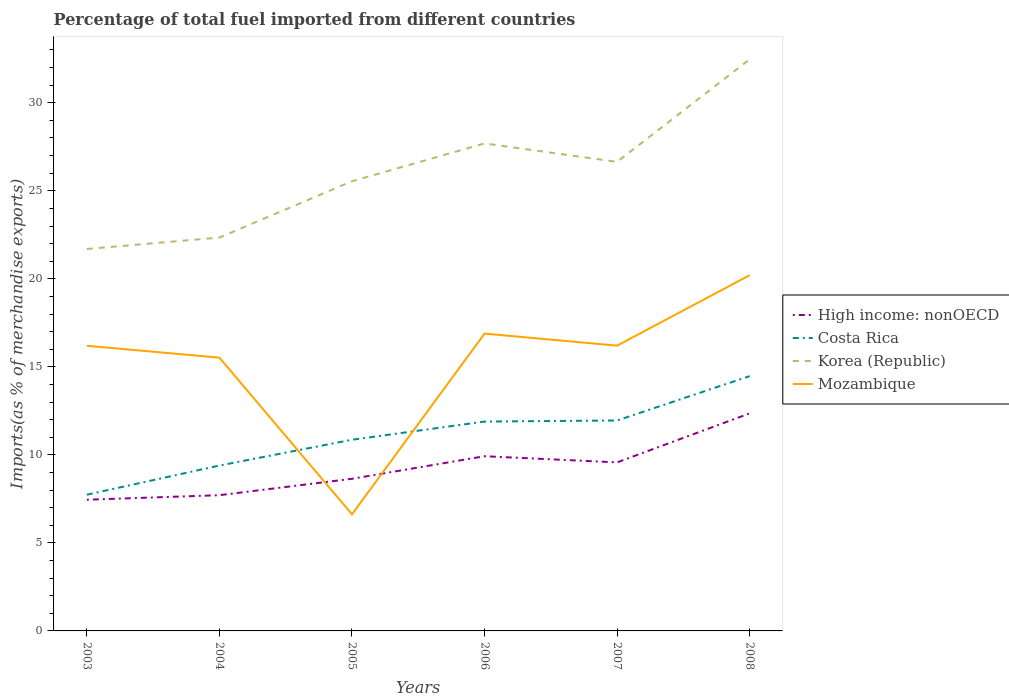Across all years, what is the maximum percentage of imports to different countries in Mozambique?
Give a very brief answer. 6.62. What is the total percentage of imports to different countries in Mozambique in the graph?
Offer a very short reply. 0.67. What is the difference between the highest and the second highest percentage of imports to different countries in Korea (Republic)?
Ensure brevity in your answer.  10.77. How many lines are there?
Provide a short and direct response. 4. How many years are there in the graph?
Provide a short and direct response. 6. What is the difference between two consecutive major ticks on the Y-axis?
Provide a succinct answer. 5. Are the values on the major ticks of Y-axis written in scientific E-notation?
Keep it short and to the point. No. Does the graph contain grids?
Your response must be concise. No. Where does the legend appear in the graph?
Offer a very short reply. Center right. How are the legend labels stacked?
Give a very brief answer. Vertical. What is the title of the graph?
Provide a short and direct response. Percentage of total fuel imported from different countries. What is the label or title of the Y-axis?
Provide a succinct answer. Imports(as % of merchandise exports). What is the Imports(as % of merchandise exports) of High income: nonOECD in 2003?
Your response must be concise. 7.45. What is the Imports(as % of merchandise exports) of Costa Rica in 2003?
Keep it short and to the point. 7.74. What is the Imports(as % of merchandise exports) of Korea (Republic) in 2003?
Provide a succinct answer. 21.69. What is the Imports(as % of merchandise exports) in Mozambique in 2003?
Make the answer very short. 16.2. What is the Imports(as % of merchandise exports) in High income: nonOECD in 2004?
Offer a very short reply. 7.71. What is the Imports(as % of merchandise exports) of Costa Rica in 2004?
Offer a terse response. 9.39. What is the Imports(as % of merchandise exports) in Korea (Republic) in 2004?
Offer a terse response. 22.34. What is the Imports(as % of merchandise exports) in Mozambique in 2004?
Provide a short and direct response. 15.52. What is the Imports(as % of merchandise exports) of High income: nonOECD in 2005?
Provide a succinct answer. 8.64. What is the Imports(as % of merchandise exports) in Costa Rica in 2005?
Provide a short and direct response. 10.86. What is the Imports(as % of merchandise exports) of Korea (Republic) in 2005?
Your answer should be very brief. 25.54. What is the Imports(as % of merchandise exports) in Mozambique in 2005?
Your answer should be compact. 6.62. What is the Imports(as % of merchandise exports) in High income: nonOECD in 2006?
Your answer should be compact. 9.92. What is the Imports(as % of merchandise exports) of Costa Rica in 2006?
Your answer should be compact. 11.89. What is the Imports(as % of merchandise exports) in Korea (Republic) in 2006?
Make the answer very short. 27.69. What is the Imports(as % of merchandise exports) of Mozambique in 2006?
Your answer should be compact. 16.89. What is the Imports(as % of merchandise exports) in High income: nonOECD in 2007?
Provide a succinct answer. 9.57. What is the Imports(as % of merchandise exports) in Costa Rica in 2007?
Offer a very short reply. 11.95. What is the Imports(as % of merchandise exports) of Korea (Republic) in 2007?
Offer a very short reply. 26.64. What is the Imports(as % of merchandise exports) of Mozambique in 2007?
Keep it short and to the point. 16.2. What is the Imports(as % of merchandise exports) in High income: nonOECD in 2008?
Your response must be concise. 12.36. What is the Imports(as % of merchandise exports) of Costa Rica in 2008?
Give a very brief answer. 14.47. What is the Imports(as % of merchandise exports) in Korea (Republic) in 2008?
Ensure brevity in your answer.  32.47. What is the Imports(as % of merchandise exports) of Mozambique in 2008?
Provide a succinct answer. 20.2. Across all years, what is the maximum Imports(as % of merchandise exports) in High income: nonOECD?
Offer a very short reply. 12.36. Across all years, what is the maximum Imports(as % of merchandise exports) of Costa Rica?
Your answer should be very brief. 14.47. Across all years, what is the maximum Imports(as % of merchandise exports) of Korea (Republic)?
Ensure brevity in your answer.  32.47. Across all years, what is the maximum Imports(as % of merchandise exports) of Mozambique?
Your answer should be compact. 20.2. Across all years, what is the minimum Imports(as % of merchandise exports) in High income: nonOECD?
Your response must be concise. 7.45. Across all years, what is the minimum Imports(as % of merchandise exports) in Costa Rica?
Your answer should be compact. 7.74. Across all years, what is the minimum Imports(as % of merchandise exports) of Korea (Republic)?
Provide a succinct answer. 21.69. Across all years, what is the minimum Imports(as % of merchandise exports) of Mozambique?
Provide a succinct answer. 6.62. What is the total Imports(as % of merchandise exports) of High income: nonOECD in the graph?
Your response must be concise. 55.66. What is the total Imports(as % of merchandise exports) of Costa Rica in the graph?
Your answer should be compact. 66.31. What is the total Imports(as % of merchandise exports) of Korea (Republic) in the graph?
Provide a succinct answer. 156.38. What is the total Imports(as % of merchandise exports) in Mozambique in the graph?
Provide a succinct answer. 91.64. What is the difference between the Imports(as % of merchandise exports) of High income: nonOECD in 2003 and that in 2004?
Make the answer very short. -0.26. What is the difference between the Imports(as % of merchandise exports) of Costa Rica in 2003 and that in 2004?
Keep it short and to the point. -1.66. What is the difference between the Imports(as % of merchandise exports) in Korea (Republic) in 2003 and that in 2004?
Your answer should be very brief. -0.65. What is the difference between the Imports(as % of merchandise exports) of Mozambique in 2003 and that in 2004?
Give a very brief answer. 0.67. What is the difference between the Imports(as % of merchandise exports) in High income: nonOECD in 2003 and that in 2005?
Your response must be concise. -1.19. What is the difference between the Imports(as % of merchandise exports) of Costa Rica in 2003 and that in 2005?
Give a very brief answer. -3.12. What is the difference between the Imports(as % of merchandise exports) in Korea (Republic) in 2003 and that in 2005?
Make the answer very short. -3.85. What is the difference between the Imports(as % of merchandise exports) in Mozambique in 2003 and that in 2005?
Give a very brief answer. 9.57. What is the difference between the Imports(as % of merchandise exports) in High income: nonOECD in 2003 and that in 2006?
Provide a short and direct response. -2.47. What is the difference between the Imports(as % of merchandise exports) in Costa Rica in 2003 and that in 2006?
Provide a short and direct response. -4.15. What is the difference between the Imports(as % of merchandise exports) in Korea (Republic) in 2003 and that in 2006?
Your answer should be very brief. -5.99. What is the difference between the Imports(as % of merchandise exports) of Mozambique in 2003 and that in 2006?
Keep it short and to the point. -0.69. What is the difference between the Imports(as % of merchandise exports) in High income: nonOECD in 2003 and that in 2007?
Ensure brevity in your answer.  -2.12. What is the difference between the Imports(as % of merchandise exports) of Costa Rica in 2003 and that in 2007?
Make the answer very short. -4.22. What is the difference between the Imports(as % of merchandise exports) in Korea (Republic) in 2003 and that in 2007?
Offer a terse response. -4.95. What is the difference between the Imports(as % of merchandise exports) in Mozambique in 2003 and that in 2007?
Your answer should be very brief. -0.01. What is the difference between the Imports(as % of merchandise exports) of High income: nonOECD in 2003 and that in 2008?
Give a very brief answer. -4.91. What is the difference between the Imports(as % of merchandise exports) of Costa Rica in 2003 and that in 2008?
Provide a short and direct response. -6.73. What is the difference between the Imports(as % of merchandise exports) of Korea (Republic) in 2003 and that in 2008?
Provide a succinct answer. -10.77. What is the difference between the Imports(as % of merchandise exports) in Mozambique in 2003 and that in 2008?
Ensure brevity in your answer.  -4.01. What is the difference between the Imports(as % of merchandise exports) of High income: nonOECD in 2004 and that in 2005?
Make the answer very short. -0.93. What is the difference between the Imports(as % of merchandise exports) of Costa Rica in 2004 and that in 2005?
Your answer should be compact. -1.46. What is the difference between the Imports(as % of merchandise exports) in Korea (Republic) in 2004 and that in 2005?
Offer a very short reply. -3.2. What is the difference between the Imports(as % of merchandise exports) of Mozambique in 2004 and that in 2005?
Provide a succinct answer. 8.9. What is the difference between the Imports(as % of merchandise exports) in High income: nonOECD in 2004 and that in 2006?
Your answer should be compact. -2.21. What is the difference between the Imports(as % of merchandise exports) of Costa Rica in 2004 and that in 2006?
Your response must be concise. -2.5. What is the difference between the Imports(as % of merchandise exports) in Korea (Republic) in 2004 and that in 2006?
Make the answer very short. -5.35. What is the difference between the Imports(as % of merchandise exports) of Mozambique in 2004 and that in 2006?
Make the answer very short. -1.37. What is the difference between the Imports(as % of merchandise exports) of High income: nonOECD in 2004 and that in 2007?
Offer a very short reply. -1.86. What is the difference between the Imports(as % of merchandise exports) in Costa Rica in 2004 and that in 2007?
Your answer should be compact. -2.56. What is the difference between the Imports(as % of merchandise exports) of Korea (Republic) in 2004 and that in 2007?
Offer a terse response. -4.3. What is the difference between the Imports(as % of merchandise exports) of Mozambique in 2004 and that in 2007?
Make the answer very short. -0.68. What is the difference between the Imports(as % of merchandise exports) in High income: nonOECD in 2004 and that in 2008?
Your answer should be very brief. -4.65. What is the difference between the Imports(as % of merchandise exports) of Costa Rica in 2004 and that in 2008?
Offer a terse response. -5.08. What is the difference between the Imports(as % of merchandise exports) of Korea (Republic) in 2004 and that in 2008?
Offer a terse response. -10.12. What is the difference between the Imports(as % of merchandise exports) in Mozambique in 2004 and that in 2008?
Make the answer very short. -4.68. What is the difference between the Imports(as % of merchandise exports) in High income: nonOECD in 2005 and that in 2006?
Keep it short and to the point. -1.28. What is the difference between the Imports(as % of merchandise exports) of Costa Rica in 2005 and that in 2006?
Make the answer very short. -1.03. What is the difference between the Imports(as % of merchandise exports) in Korea (Republic) in 2005 and that in 2006?
Offer a very short reply. -2.15. What is the difference between the Imports(as % of merchandise exports) of Mozambique in 2005 and that in 2006?
Offer a terse response. -10.26. What is the difference between the Imports(as % of merchandise exports) in High income: nonOECD in 2005 and that in 2007?
Your response must be concise. -0.93. What is the difference between the Imports(as % of merchandise exports) of Costa Rica in 2005 and that in 2007?
Provide a short and direct response. -1.09. What is the difference between the Imports(as % of merchandise exports) of Korea (Republic) in 2005 and that in 2007?
Keep it short and to the point. -1.1. What is the difference between the Imports(as % of merchandise exports) in Mozambique in 2005 and that in 2007?
Your answer should be compact. -9.58. What is the difference between the Imports(as % of merchandise exports) of High income: nonOECD in 2005 and that in 2008?
Offer a terse response. -3.72. What is the difference between the Imports(as % of merchandise exports) in Costa Rica in 2005 and that in 2008?
Your answer should be compact. -3.61. What is the difference between the Imports(as % of merchandise exports) in Korea (Republic) in 2005 and that in 2008?
Make the answer very short. -6.92. What is the difference between the Imports(as % of merchandise exports) of Mozambique in 2005 and that in 2008?
Give a very brief answer. -13.58. What is the difference between the Imports(as % of merchandise exports) of High income: nonOECD in 2006 and that in 2007?
Offer a very short reply. 0.35. What is the difference between the Imports(as % of merchandise exports) in Costa Rica in 2006 and that in 2007?
Your answer should be compact. -0.06. What is the difference between the Imports(as % of merchandise exports) in Korea (Republic) in 2006 and that in 2007?
Your answer should be compact. 1.04. What is the difference between the Imports(as % of merchandise exports) in Mozambique in 2006 and that in 2007?
Make the answer very short. 0.68. What is the difference between the Imports(as % of merchandise exports) of High income: nonOECD in 2006 and that in 2008?
Provide a short and direct response. -2.43. What is the difference between the Imports(as % of merchandise exports) of Costa Rica in 2006 and that in 2008?
Provide a succinct answer. -2.58. What is the difference between the Imports(as % of merchandise exports) in Korea (Republic) in 2006 and that in 2008?
Provide a succinct answer. -4.78. What is the difference between the Imports(as % of merchandise exports) in Mozambique in 2006 and that in 2008?
Keep it short and to the point. -3.32. What is the difference between the Imports(as % of merchandise exports) of High income: nonOECD in 2007 and that in 2008?
Your response must be concise. -2.78. What is the difference between the Imports(as % of merchandise exports) of Costa Rica in 2007 and that in 2008?
Your answer should be very brief. -2.52. What is the difference between the Imports(as % of merchandise exports) in Korea (Republic) in 2007 and that in 2008?
Keep it short and to the point. -5.82. What is the difference between the Imports(as % of merchandise exports) in Mozambique in 2007 and that in 2008?
Offer a very short reply. -4. What is the difference between the Imports(as % of merchandise exports) of High income: nonOECD in 2003 and the Imports(as % of merchandise exports) of Costa Rica in 2004?
Provide a succinct answer. -1.94. What is the difference between the Imports(as % of merchandise exports) in High income: nonOECD in 2003 and the Imports(as % of merchandise exports) in Korea (Republic) in 2004?
Provide a succinct answer. -14.89. What is the difference between the Imports(as % of merchandise exports) of High income: nonOECD in 2003 and the Imports(as % of merchandise exports) of Mozambique in 2004?
Ensure brevity in your answer.  -8.07. What is the difference between the Imports(as % of merchandise exports) in Costa Rica in 2003 and the Imports(as % of merchandise exports) in Korea (Republic) in 2004?
Provide a succinct answer. -14.61. What is the difference between the Imports(as % of merchandise exports) of Costa Rica in 2003 and the Imports(as % of merchandise exports) of Mozambique in 2004?
Provide a short and direct response. -7.79. What is the difference between the Imports(as % of merchandise exports) of Korea (Republic) in 2003 and the Imports(as % of merchandise exports) of Mozambique in 2004?
Offer a terse response. 6.17. What is the difference between the Imports(as % of merchandise exports) of High income: nonOECD in 2003 and the Imports(as % of merchandise exports) of Costa Rica in 2005?
Your answer should be very brief. -3.41. What is the difference between the Imports(as % of merchandise exports) of High income: nonOECD in 2003 and the Imports(as % of merchandise exports) of Korea (Republic) in 2005?
Give a very brief answer. -18.09. What is the difference between the Imports(as % of merchandise exports) of High income: nonOECD in 2003 and the Imports(as % of merchandise exports) of Mozambique in 2005?
Keep it short and to the point. 0.83. What is the difference between the Imports(as % of merchandise exports) of Costa Rica in 2003 and the Imports(as % of merchandise exports) of Korea (Republic) in 2005?
Keep it short and to the point. -17.81. What is the difference between the Imports(as % of merchandise exports) of Costa Rica in 2003 and the Imports(as % of merchandise exports) of Mozambique in 2005?
Make the answer very short. 1.11. What is the difference between the Imports(as % of merchandise exports) in Korea (Republic) in 2003 and the Imports(as % of merchandise exports) in Mozambique in 2005?
Provide a succinct answer. 15.07. What is the difference between the Imports(as % of merchandise exports) of High income: nonOECD in 2003 and the Imports(as % of merchandise exports) of Costa Rica in 2006?
Ensure brevity in your answer.  -4.44. What is the difference between the Imports(as % of merchandise exports) in High income: nonOECD in 2003 and the Imports(as % of merchandise exports) in Korea (Republic) in 2006?
Your answer should be compact. -20.24. What is the difference between the Imports(as % of merchandise exports) of High income: nonOECD in 2003 and the Imports(as % of merchandise exports) of Mozambique in 2006?
Make the answer very short. -9.44. What is the difference between the Imports(as % of merchandise exports) in Costa Rica in 2003 and the Imports(as % of merchandise exports) in Korea (Republic) in 2006?
Provide a succinct answer. -19.95. What is the difference between the Imports(as % of merchandise exports) in Costa Rica in 2003 and the Imports(as % of merchandise exports) in Mozambique in 2006?
Ensure brevity in your answer.  -9.15. What is the difference between the Imports(as % of merchandise exports) in Korea (Republic) in 2003 and the Imports(as % of merchandise exports) in Mozambique in 2006?
Your answer should be very brief. 4.81. What is the difference between the Imports(as % of merchandise exports) of High income: nonOECD in 2003 and the Imports(as % of merchandise exports) of Costa Rica in 2007?
Ensure brevity in your answer.  -4.5. What is the difference between the Imports(as % of merchandise exports) in High income: nonOECD in 2003 and the Imports(as % of merchandise exports) in Korea (Republic) in 2007?
Offer a terse response. -19.19. What is the difference between the Imports(as % of merchandise exports) of High income: nonOECD in 2003 and the Imports(as % of merchandise exports) of Mozambique in 2007?
Give a very brief answer. -8.75. What is the difference between the Imports(as % of merchandise exports) in Costa Rica in 2003 and the Imports(as % of merchandise exports) in Korea (Republic) in 2007?
Make the answer very short. -18.91. What is the difference between the Imports(as % of merchandise exports) in Costa Rica in 2003 and the Imports(as % of merchandise exports) in Mozambique in 2007?
Make the answer very short. -8.47. What is the difference between the Imports(as % of merchandise exports) in Korea (Republic) in 2003 and the Imports(as % of merchandise exports) in Mozambique in 2007?
Provide a short and direct response. 5.49. What is the difference between the Imports(as % of merchandise exports) of High income: nonOECD in 2003 and the Imports(as % of merchandise exports) of Costa Rica in 2008?
Ensure brevity in your answer.  -7.02. What is the difference between the Imports(as % of merchandise exports) of High income: nonOECD in 2003 and the Imports(as % of merchandise exports) of Korea (Republic) in 2008?
Your answer should be compact. -25.02. What is the difference between the Imports(as % of merchandise exports) of High income: nonOECD in 2003 and the Imports(as % of merchandise exports) of Mozambique in 2008?
Ensure brevity in your answer.  -12.75. What is the difference between the Imports(as % of merchandise exports) in Costa Rica in 2003 and the Imports(as % of merchandise exports) in Korea (Republic) in 2008?
Give a very brief answer. -24.73. What is the difference between the Imports(as % of merchandise exports) in Costa Rica in 2003 and the Imports(as % of merchandise exports) in Mozambique in 2008?
Ensure brevity in your answer.  -12.47. What is the difference between the Imports(as % of merchandise exports) of Korea (Republic) in 2003 and the Imports(as % of merchandise exports) of Mozambique in 2008?
Make the answer very short. 1.49. What is the difference between the Imports(as % of merchandise exports) in High income: nonOECD in 2004 and the Imports(as % of merchandise exports) in Costa Rica in 2005?
Provide a succinct answer. -3.15. What is the difference between the Imports(as % of merchandise exports) of High income: nonOECD in 2004 and the Imports(as % of merchandise exports) of Korea (Republic) in 2005?
Your answer should be compact. -17.83. What is the difference between the Imports(as % of merchandise exports) of High income: nonOECD in 2004 and the Imports(as % of merchandise exports) of Mozambique in 2005?
Your answer should be very brief. 1.09. What is the difference between the Imports(as % of merchandise exports) in Costa Rica in 2004 and the Imports(as % of merchandise exports) in Korea (Republic) in 2005?
Your answer should be compact. -16.15. What is the difference between the Imports(as % of merchandise exports) in Costa Rica in 2004 and the Imports(as % of merchandise exports) in Mozambique in 2005?
Offer a terse response. 2.77. What is the difference between the Imports(as % of merchandise exports) of Korea (Republic) in 2004 and the Imports(as % of merchandise exports) of Mozambique in 2005?
Keep it short and to the point. 15.72. What is the difference between the Imports(as % of merchandise exports) in High income: nonOECD in 2004 and the Imports(as % of merchandise exports) in Costa Rica in 2006?
Make the answer very short. -4.18. What is the difference between the Imports(as % of merchandise exports) of High income: nonOECD in 2004 and the Imports(as % of merchandise exports) of Korea (Republic) in 2006?
Ensure brevity in your answer.  -19.98. What is the difference between the Imports(as % of merchandise exports) of High income: nonOECD in 2004 and the Imports(as % of merchandise exports) of Mozambique in 2006?
Make the answer very short. -9.18. What is the difference between the Imports(as % of merchandise exports) of Costa Rica in 2004 and the Imports(as % of merchandise exports) of Korea (Republic) in 2006?
Your answer should be very brief. -18.29. What is the difference between the Imports(as % of merchandise exports) in Costa Rica in 2004 and the Imports(as % of merchandise exports) in Mozambique in 2006?
Provide a short and direct response. -7.49. What is the difference between the Imports(as % of merchandise exports) in Korea (Republic) in 2004 and the Imports(as % of merchandise exports) in Mozambique in 2006?
Offer a terse response. 5.46. What is the difference between the Imports(as % of merchandise exports) in High income: nonOECD in 2004 and the Imports(as % of merchandise exports) in Costa Rica in 2007?
Your answer should be very brief. -4.24. What is the difference between the Imports(as % of merchandise exports) of High income: nonOECD in 2004 and the Imports(as % of merchandise exports) of Korea (Republic) in 2007?
Make the answer very short. -18.93. What is the difference between the Imports(as % of merchandise exports) of High income: nonOECD in 2004 and the Imports(as % of merchandise exports) of Mozambique in 2007?
Your answer should be compact. -8.49. What is the difference between the Imports(as % of merchandise exports) in Costa Rica in 2004 and the Imports(as % of merchandise exports) in Korea (Republic) in 2007?
Ensure brevity in your answer.  -17.25. What is the difference between the Imports(as % of merchandise exports) of Costa Rica in 2004 and the Imports(as % of merchandise exports) of Mozambique in 2007?
Your response must be concise. -6.81. What is the difference between the Imports(as % of merchandise exports) of Korea (Republic) in 2004 and the Imports(as % of merchandise exports) of Mozambique in 2007?
Your answer should be very brief. 6.14. What is the difference between the Imports(as % of merchandise exports) of High income: nonOECD in 2004 and the Imports(as % of merchandise exports) of Costa Rica in 2008?
Provide a succinct answer. -6.76. What is the difference between the Imports(as % of merchandise exports) in High income: nonOECD in 2004 and the Imports(as % of merchandise exports) in Korea (Republic) in 2008?
Give a very brief answer. -24.76. What is the difference between the Imports(as % of merchandise exports) in High income: nonOECD in 2004 and the Imports(as % of merchandise exports) in Mozambique in 2008?
Keep it short and to the point. -12.49. What is the difference between the Imports(as % of merchandise exports) in Costa Rica in 2004 and the Imports(as % of merchandise exports) in Korea (Republic) in 2008?
Offer a terse response. -23.07. What is the difference between the Imports(as % of merchandise exports) in Costa Rica in 2004 and the Imports(as % of merchandise exports) in Mozambique in 2008?
Give a very brief answer. -10.81. What is the difference between the Imports(as % of merchandise exports) of Korea (Republic) in 2004 and the Imports(as % of merchandise exports) of Mozambique in 2008?
Provide a short and direct response. 2.14. What is the difference between the Imports(as % of merchandise exports) of High income: nonOECD in 2005 and the Imports(as % of merchandise exports) of Costa Rica in 2006?
Keep it short and to the point. -3.25. What is the difference between the Imports(as % of merchandise exports) of High income: nonOECD in 2005 and the Imports(as % of merchandise exports) of Korea (Republic) in 2006?
Keep it short and to the point. -19.05. What is the difference between the Imports(as % of merchandise exports) in High income: nonOECD in 2005 and the Imports(as % of merchandise exports) in Mozambique in 2006?
Offer a very short reply. -8.25. What is the difference between the Imports(as % of merchandise exports) in Costa Rica in 2005 and the Imports(as % of merchandise exports) in Korea (Republic) in 2006?
Your answer should be compact. -16.83. What is the difference between the Imports(as % of merchandise exports) of Costa Rica in 2005 and the Imports(as % of merchandise exports) of Mozambique in 2006?
Ensure brevity in your answer.  -6.03. What is the difference between the Imports(as % of merchandise exports) in Korea (Republic) in 2005 and the Imports(as % of merchandise exports) in Mozambique in 2006?
Keep it short and to the point. 8.66. What is the difference between the Imports(as % of merchandise exports) in High income: nonOECD in 2005 and the Imports(as % of merchandise exports) in Costa Rica in 2007?
Offer a very short reply. -3.31. What is the difference between the Imports(as % of merchandise exports) of High income: nonOECD in 2005 and the Imports(as % of merchandise exports) of Korea (Republic) in 2007?
Your answer should be compact. -18. What is the difference between the Imports(as % of merchandise exports) of High income: nonOECD in 2005 and the Imports(as % of merchandise exports) of Mozambique in 2007?
Keep it short and to the point. -7.56. What is the difference between the Imports(as % of merchandise exports) of Costa Rica in 2005 and the Imports(as % of merchandise exports) of Korea (Republic) in 2007?
Your answer should be very brief. -15.78. What is the difference between the Imports(as % of merchandise exports) of Costa Rica in 2005 and the Imports(as % of merchandise exports) of Mozambique in 2007?
Offer a terse response. -5.34. What is the difference between the Imports(as % of merchandise exports) of Korea (Republic) in 2005 and the Imports(as % of merchandise exports) of Mozambique in 2007?
Your answer should be very brief. 9.34. What is the difference between the Imports(as % of merchandise exports) in High income: nonOECD in 2005 and the Imports(as % of merchandise exports) in Costa Rica in 2008?
Your response must be concise. -5.83. What is the difference between the Imports(as % of merchandise exports) of High income: nonOECD in 2005 and the Imports(as % of merchandise exports) of Korea (Republic) in 2008?
Give a very brief answer. -23.83. What is the difference between the Imports(as % of merchandise exports) in High income: nonOECD in 2005 and the Imports(as % of merchandise exports) in Mozambique in 2008?
Provide a short and direct response. -11.56. What is the difference between the Imports(as % of merchandise exports) of Costa Rica in 2005 and the Imports(as % of merchandise exports) of Korea (Republic) in 2008?
Make the answer very short. -21.61. What is the difference between the Imports(as % of merchandise exports) of Costa Rica in 2005 and the Imports(as % of merchandise exports) of Mozambique in 2008?
Your response must be concise. -9.35. What is the difference between the Imports(as % of merchandise exports) in Korea (Republic) in 2005 and the Imports(as % of merchandise exports) in Mozambique in 2008?
Make the answer very short. 5.34. What is the difference between the Imports(as % of merchandise exports) in High income: nonOECD in 2006 and the Imports(as % of merchandise exports) in Costa Rica in 2007?
Make the answer very short. -2.03. What is the difference between the Imports(as % of merchandise exports) of High income: nonOECD in 2006 and the Imports(as % of merchandise exports) of Korea (Republic) in 2007?
Your response must be concise. -16.72. What is the difference between the Imports(as % of merchandise exports) of High income: nonOECD in 2006 and the Imports(as % of merchandise exports) of Mozambique in 2007?
Provide a succinct answer. -6.28. What is the difference between the Imports(as % of merchandise exports) of Costa Rica in 2006 and the Imports(as % of merchandise exports) of Korea (Republic) in 2007?
Offer a terse response. -14.75. What is the difference between the Imports(as % of merchandise exports) in Costa Rica in 2006 and the Imports(as % of merchandise exports) in Mozambique in 2007?
Offer a terse response. -4.31. What is the difference between the Imports(as % of merchandise exports) in Korea (Republic) in 2006 and the Imports(as % of merchandise exports) in Mozambique in 2007?
Give a very brief answer. 11.48. What is the difference between the Imports(as % of merchandise exports) in High income: nonOECD in 2006 and the Imports(as % of merchandise exports) in Costa Rica in 2008?
Offer a terse response. -4.55. What is the difference between the Imports(as % of merchandise exports) in High income: nonOECD in 2006 and the Imports(as % of merchandise exports) in Korea (Republic) in 2008?
Your answer should be very brief. -22.54. What is the difference between the Imports(as % of merchandise exports) of High income: nonOECD in 2006 and the Imports(as % of merchandise exports) of Mozambique in 2008?
Your response must be concise. -10.28. What is the difference between the Imports(as % of merchandise exports) of Costa Rica in 2006 and the Imports(as % of merchandise exports) of Korea (Republic) in 2008?
Your answer should be compact. -20.58. What is the difference between the Imports(as % of merchandise exports) of Costa Rica in 2006 and the Imports(as % of merchandise exports) of Mozambique in 2008?
Provide a short and direct response. -8.31. What is the difference between the Imports(as % of merchandise exports) of Korea (Republic) in 2006 and the Imports(as % of merchandise exports) of Mozambique in 2008?
Your answer should be compact. 7.48. What is the difference between the Imports(as % of merchandise exports) in High income: nonOECD in 2007 and the Imports(as % of merchandise exports) in Costa Rica in 2008?
Make the answer very short. -4.9. What is the difference between the Imports(as % of merchandise exports) of High income: nonOECD in 2007 and the Imports(as % of merchandise exports) of Korea (Republic) in 2008?
Provide a succinct answer. -22.89. What is the difference between the Imports(as % of merchandise exports) of High income: nonOECD in 2007 and the Imports(as % of merchandise exports) of Mozambique in 2008?
Give a very brief answer. -10.63. What is the difference between the Imports(as % of merchandise exports) of Costa Rica in 2007 and the Imports(as % of merchandise exports) of Korea (Republic) in 2008?
Give a very brief answer. -20.51. What is the difference between the Imports(as % of merchandise exports) of Costa Rica in 2007 and the Imports(as % of merchandise exports) of Mozambique in 2008?
Provide a short and direct response. -8.25. What is the difference between the Imports(as % of merchandise exports) of Korea (Republic) in 2007 and the Imports(as % of merchandise exports) of Mozambique in 2008?
Your answer should be very brief. 6.44. What is the average Imports(as % of merchandise exports) in High income: nonOECD per year?
Your answer should be very brief. 9.28. What is the average Imports(as % of merchandise exports) of Costa Rica per year?
Your answer should be very brief. 11.05. What is the average Imports(as % of merchandise exports) in Korea (Republic) per year?
Provide a short and direct response. 26.06. What is the average Imports(as % of merchandise exports) in Mozambique per year?
Give a very brief answer. 15.27. In the year 2003, what is the difference between the Imports(as % of merchandise exports) in High income: nonOECD and Imports(as % of merchandise exports) in Costa Rica?
Ensure brevity in your answer.  -0.29. In the year 2003, what is the difference between the Imports(as % of merchandise exports) in High income: nonOECD and Imports(as % of merchandise exports) in Korea (Republic)?
Provide a short and direct response. -14.24. In the year 2003, what is the difference between the Imports(as % of merchandise exports) of High income: nonOECD and Imports(as % of merchandise exports) of Mozambique?
Offer a terse response. -8.74. In the year 2003, what is the difference between the Imports(as % of merchandise exports) in Costa Rica and Imports(as % of merchandise exports) in Korea (Republic)?
Your answer should be very brief. -13.96. In the year 2003, what is the difference between the Imports(as % of merchandise exports) of Costa Rica and Imports(as % of merchandise exports) of Mozambique?
Make the answer very short. -8.46. In the year 2003, what is the difference between the Imports(as % of merchandise exports) of Korea (Republic) and Imports(as % of merchandise exports) of Mozambique?
Give a very brief answer. 5.5. In the year 2004, what is the difference between the Imports(as % of merchandise exports) of High income: nonOECD and Imports(as % of merchandise exports) of Costa Rica?
Your answer should be very brief. -1.68. In the year 2004, what is the difference between the Imports(as % of merchandise exports) in High income: nonOECD and Imports(as % of merchandise exports) in Korea (Republic)?
Give a very brief answer. -14.63. In the year 2004, what is the difference between the Imports(as % of merchandise exports) of High income: nonOECD and Imports(as % of merchandise exports) of Mozambique?
Your answer should be compact. -7.81. In the year 2004, what is the difference between the Imports(as % of merchandise exports) of Costa Rica and Imports(as % of merchandise exports) of Korea (Republic)?
Your answer should be compact. -12.95. In the year 2004, what is the difference between the Imports(as % of merchandise exports) of Costa Rica and Imports(as % of merchandise exports) of Mozambique?
Offer a terse response. -6.13. In the year 2004, what is the difference between the Imports(as % of merchandise exports) of Korea (Republic) and Imports(as % of merchandise exports) of Mozambique?
Your answer should be very brief. 6.82. In the year 2005, what is the difference between the Imports(as % of merchandise exports) in High income: nonOECD and Imports(as % of merchandise exports) in Costa Rica?
Your answer should be very brief. -2.22. In the year 2005, what is the difference between the Imports(as % of merchandise exports) of High income: nonOECD and Imports(as % of merchandise exports) of Korea (Republic)?
Make the answer very short. -16.9. In the year 2005, what is the difference between the Imports(as % of merchandise exports) in High income: nonOECD and Imports(as % of merchandise exports) in Mozambique?
Make the answer very short. 2.02. In the year 2005, what is the difference between the Imports(as % of merchandise exports) in Costa Rica and Imports(as % of merchandise exports) in Korea (Republic)?
Give a very brief answer. -14.68. In the year 2005, what is the difference between the Imports(as % of merchandise exports) in Costa Rica and Imports(as % of merchandise exports) in Mozambique?
Keep it short and to the point. 4.23. In the year 2005, what is the difference between the Imports(as % of merchandise exports) of Korea (Republic) and Imports(as % of merchandise exports) of Mozambique?
Provide a short and direct response. 18.92. In the year 2006, what is the difference between the Imports(as % of merchandise exports) of High income: nonOECD and Imports(as % of merchandise exports) of Costa Rica?
Make the answer very short. -1.97. In the year 2006, what is the difference between the Imports(as % of merchandise exports) in High income: nonOECD and Imports(as % of merchandise exports) in Korea (Republic)?
Your answer should be compact. -17.77. In the year 2006, what is the difference between the Imports(as % of merchandise exports) of High income: nonOECD and Imports(as % of merchandise exports) of Mozambique?
Provide a succinct answer. -6.97. In the year 2006, what is the difference between the Imports(as % of merchandise exports) of Costa Rica and Imports(as % of merchandise exports) of Korea (Republic)?
Keep it short and to the point. -15.8. In the year 2006, what is the difference between the Imports(as % of merchandise exports) of Costa Rica and Imports(as % of merchandise exports) of Mozambique?
Your answer should be compact. -5. In the year 2006, what is the difference between the Imports(as % of merchandise exports) in Korea (Republic) and Imports(as % of merchandise exports) in Mozambique?
Make the answer very short. 10.8. In the year 2007, what is the difference between the Imports(as % of merchandise exports) in High income: nonOECD and Imports(as % of merchandise exports) in Costa Rica?
Make the answer very short. -2.38. In the year 2007, what is the difference between the Imports(as % of merchandise exports) of High income: nonOECD and Imports(as % of merchandise exports) of Korea (Republic)?
Make the answer very short. -17.07. In the year 2007, what is the difference between the Imports(as % of merchandise exports) of High income: nonOECD and Imports(as % of merchandise exports) of Mozambique?
Your answer should be very brief. -6.63. In the year 2007, what is the difference between the Imports(as % of merchandise exports) of Costa Rica and Imports(as % of merchandise exports) of Korea (Republic)?
Keep it short and to the point. -14.69. In the year 2007, what is the difference between the Imports(as % of merchandise exports) of Costa Rica and Imports(as % of merchandise exports) of Mozambique?
Your response must be concise. -4.25. In the year 2007, what is the difference between the Imports(as % of merchandise exports) of Korea (Republic) and Imports(as % of merchandise exports) of Mozambique?
Offer a very short reply. 10.44. In the year 2008, what is the difference between the Imports(as % of merchandise exports) in High income: nonOECD and Imports(as % of merchandise exports) in Costa Rica?
Provide a succinct answer. -2.11. In the year 2008, what is the difference between the Imports(as % of merchandise exports) in High income: nonOECD and Imports(as % of merchandise exports) in Korea (Republic)?
Your answer should be very brief. -20.11. In the year 2008, what is the difference between the Imports(as % of merchandise exports) of High income: nonOECD and Imports(as % of merchandise exports) of Mozambique?
Offer a very short reply. -7.85. In the year 2008, what is the difference between the Imports(as % of merchandise exports) in Costa Rica and Imports(as % of merchandise exports) in Korea (Republic)?
Make the answer very short. -18. In the year 2008, what is the difference between the Imports(as % of merchandise exports) in Costa Rica and Imports(as % of merchandise exports) in Mozambique?
Provide a short and direct response. -5.73. In the year 2008, what is the difference between the Imports(as % of merchandise exports) in Korea (Republic) and Imports(as % of merchandise exports) in Mozambique?
Offer a very short reply. 12.26. What is the ratio of the Imports(as % of merchandise exports) in High income: nonOECD in 2003 to that in 2004?
Ensure brevity in your answer.  0.97. What is the ratio of the Imports(as % of merchandise exports) of Costa Rica in 2003 to that in 2004?
Your answer should be compact. 0.82. What is the ratio of the Imports(as % of merchandise exports) in Mozambique in 2003 to that in 2004?
Provide a succinct answer. 1.04. What is the ratio of the Imports(as % of merchandise exports) in High income: nonOECD in 2003 to that in 2005?
Ensure brevity in your answer.  0.86. What is the ratio of the Imports(as % of merchandise exports) in Costa Rica in 2003 to that in 2005?
Your answer should be very brief. 0.71. What is the ratio of the Imports(as % of merchandise exports) of Korea (Republic) in 2003 to that in 2005?
Your answer should be compact. 0.85. What is the ratio of the Imports(as % of merchandise exports) in Mozambique in 2003 to that in 2005?
Keep it short and to the point. 2.44. What is the ratio of the Imports(as % of merchandise exports) in High income: nonOECD in 2003 to that in 2006?
Make the answer very short. 0.75. What is the ratio of the Imports(as % of merchandise exports) of Costa Rica in 2003 to that in 2006?
Ensure brevity in your answer.  0.65. What is the ratio of the Imports(as % of merchandise exports) in Korea (Republic) in 2003 to that in 2006?
Provide a succinct answer. 0.78. What is the ratio of the Imports(as % of merchandise exports) in Mozambique in 2003 to that in 2006?
Provide a short and direct response. 0.96. What is the ratio of the Imports(as % of merchandise exports) in High income: nonOECD in 2003 to that in 2007?
Ensure brevity in your answer.  0.78. What is the ratio of the Imports(as % of merchandise exports) in Costa Rica in 2003 to that in 2007?
Offer a very short reply. 0.65. What is the ratio of the Imports(as % of merchandise exports) in Korea (Republic) in 2003 to that in 2007?
Provide a short and direct response. 0.81. What is the ratio of the Imports(as % of merchandise exports) of Mozambique in 2003 to that in 2007?
Keep it short and to the point. 1. What is the ratio of the Imports(as % of merchandise exports) in High income: nonOECD in 2003 to that in 2008?
Your response must be concise. 0.6. What is the ratio of the Imports(as % of merchandise exports) in Costa Rica in 2003 to that in 2008?
Keep it short and to the point. 0.53. What is the ratio of the Imports(as % of merchandise exports) in Korea (Republic) in 2003 to that in 2008?
Give a very brief answer. 0.67. What is the ratio of the Imports(as % of merchandise exports) of Mozambique in 2003 to that in 2008?
Your answer should be very brief. 0.8. What is the ratio of the Imports(as % of merchandise exports) in High income: nonOECD in 2004 to that in 2005?
Provide a succinct answer. 0.89. What is the ratio of the Imports(as % of merchandise exports) in Costa Rica in 2004 to that in 2005?
Give a very brief answer. 0.87. What is the ratio of the Imports(as % of merchandise exports) of Korea (Republic) in 2004 to that in 2005?
Provide a succinct answer. 0.87. What is the ratio of the Imports(as % of merchandise exports) in Mozambique in 2004 to that in 2005?
Offer a terse response. 2.34. What is the ratio of the Imports(as % of merchandise exports) of High income: nonOECD in 2004 to that in 2006?
Keep it short and to the point. 0.78. What is the ratio of the Imports(as % of merchandise exports) in Costa Rica in 2004 to that in 2006?
Ensure brevity in your answer.  0.79. What is the ratio of the Imports(as % of merchandise exports) in Korea (Republic) in 2004 to that in 2006?
Make the answer very short. 0.81. What is the ratio of the Imports(as % of merchandise exports) in Mozambique in 2004 to that in 2006?
Your answer should be very brief. 0.92. What is the ratio of the Imports(as % of merchandise exports) in High income: nonOECD in 2004 to that in 2007?
Offer a terse response. 0.81. What is the ratio of the Imports(as % of merchandise exports) in Costa Rica in 2004 to that in 2007?
Make the answer very short. 0.79. What is the ratio of the Imports(as % of merchandise exports) of Korea (Republic) in 2004 to that in 2007?
Your response must be concise. 0.84. What is the ratio of the Imports(as % of merchandise exports) in Mozambique in 2004 to that in 2007?
Offer a very short reply. 0.96. What is the ratio of the Imports(as % of merchandise exports) in High income: nonOECD in 2004 to that in 2008?
Your answer should be compact. 0.62. What is the ratio of the Imports(as % of merchandise exports) in Costa Rica in 2004 to that in 2008?
Offer a terse response. 0.65. What is the ratio of the Imports(as % of merchandise exports) in Korea (Republic) in 2004 to that in 2008?
Give a very brief answer. 0.69. What is the ratio of the Imports(as % of merchandise exports) of Mozambique in 2004 to that in 2008?
Provide a short and direct response. 0.77. What is the ratio of the Imports(as % of merchandise exports) of High income: nonOECD in 2005 to that in 2006?
Offer a very short reply. 0.87. What is the ratio of the Imports(as % of merchandise exports) of Costa Rica in 2005 to that in 2006?
Your answer should be compact. 0.91. What is the ratio of the Imports(as % of merchandise exports) of Korea (Republic) in 2005 to that in 2006?
Make the answer very short. 0.92. What is the ratio of the Imports(as % of merchandise exports) in Mozambique in 2005 to that in 2006?
Provide a succinct answer. 0.39. What is the ratio of the Imports(as % of merchandise exports) in High income: nonOECD in 2005 to that in 2007?
Your answer should be compact. 0.9. What is the ratio of the Imports(as % of merchandise exports) of Costa Rica in 2005 to that in 2007?
Ensure brevity in your answer.  0.91. What is the ratio of the Imports(as % of merchandise exports) in Korea (Republic) in 2005 to that in 2007?
Offer a very short reply. 0.96. What is the ratio of the Imports(as % of merchandise exports) in Mozambique in 2005 to that in 2007?
Provide a short and direct response. 0.41. What is the ratio of the Imports(as % of merchandise exports) in High income: nonOECD in 2005 to that in 2008?
Your response must be concise. 0.7. What is the ratio of the Imports(as % of merchandise exports) in Costa Rica in 2005 to that in 2008?
Offer a very short reply. 0.75. What is the ratio of the Imports(as % of merchandise exports) in Korea (Republic) in 2005 to that in 2008?
Make the answer very short. 0.79. What is the ratio of the Imports(as % of merchandise exports) in Mozambique in 2005 to that in 2008?
Keep it short and to the point. 0.33. What is the ratio of the Imports(as % of merchandise exports) in High income: nonOECD in 2006 to that in 2007?
Offer a terse response. 1.04. What is the ratio of the Imports(as % of merchandise exports) in Korea (Republic) in 2006 to that in 2007?
Offer a very short reply. 1.04. What is the ratio of the Imports(as % of merchandise exports) in Mozambique in 2006 to that in 2007?
Your response must be concise. 1.04. What is the ratio of the Imports(as % of merchandise exports) of High income: nonOECD in 2006 to that in 2008?
Ensure brevity in your answer.  0.8. What is the ratio of the Imports(as % of merchandise exports) of Costa Rica in 2006 to that in 2008?
Your answer should be very brief. 0.82. What is the ratio of the Imports(as % of merchandise exports) in Korea (Republic) in 2006 to that in 2008?
Offer a very short reply. 0.85. What is the ratio of the Imports(as % of merchandise exports) of Mozambique in 2006 to that in 2008?
Your answer should be compact. 0.84. What is the ratio of the Imports(as % of merchandise exports) in High income: nonOECD in 2007 to that in 2008?
Ensure brevity in your answer.  0.77. What is the ratio of the Imports(as % of merchandise exports) of Costa Rica in 2007 to that in 2008?
Give a very brief answer. 0.83. What is the ratio of the Imports(as % of merchandise exports) of Korea (Republic) in 2007 to that in 2008?
Provide a short and direct response. 0.82. What is the ratio of the Imports(as % of merchandise exports) of Mozambique in 2007 to that in 2008?
Offer a terse response. 0.8. What is the difference between the highest and the second highest Imports(as % of merchandise exports) of High income: nonOECD?
Your answer should be very brief. 2.43. What is the difference between the highest and the second highest Imports(as % of merchandise exports) of Costa Rica?
Provide a short and direct response. 2.52. What is the difference between the highest and the second highest Imports(as % of merchandise exports) in Korea (Republic)?
Ensure brevity in your answer.  4.78. What is the difference between the highest and the second highest Imports(as % of merchandise exports) of Mozambique?
Offer a very short reply. 3.32. What is the difference between the highest and the lowest Imports(as % of merchandise exports) of High income: nonOECD?
Make the answer very short. 4.91. What is the difference between the highest and the lowest Imports(as % of merchandise exports) in Costa Rica?
Your response must be concise. 6.73. What is the difference between the highest and the lowest Imports(as % of merchandise exports) of Korea (Republic)?
Your response must be concise. 10.77. What is the difference between the highest and the lowest Imports(as % of merchandise exports) of Mozambique?
Your answer should be very brief. 13.58. 